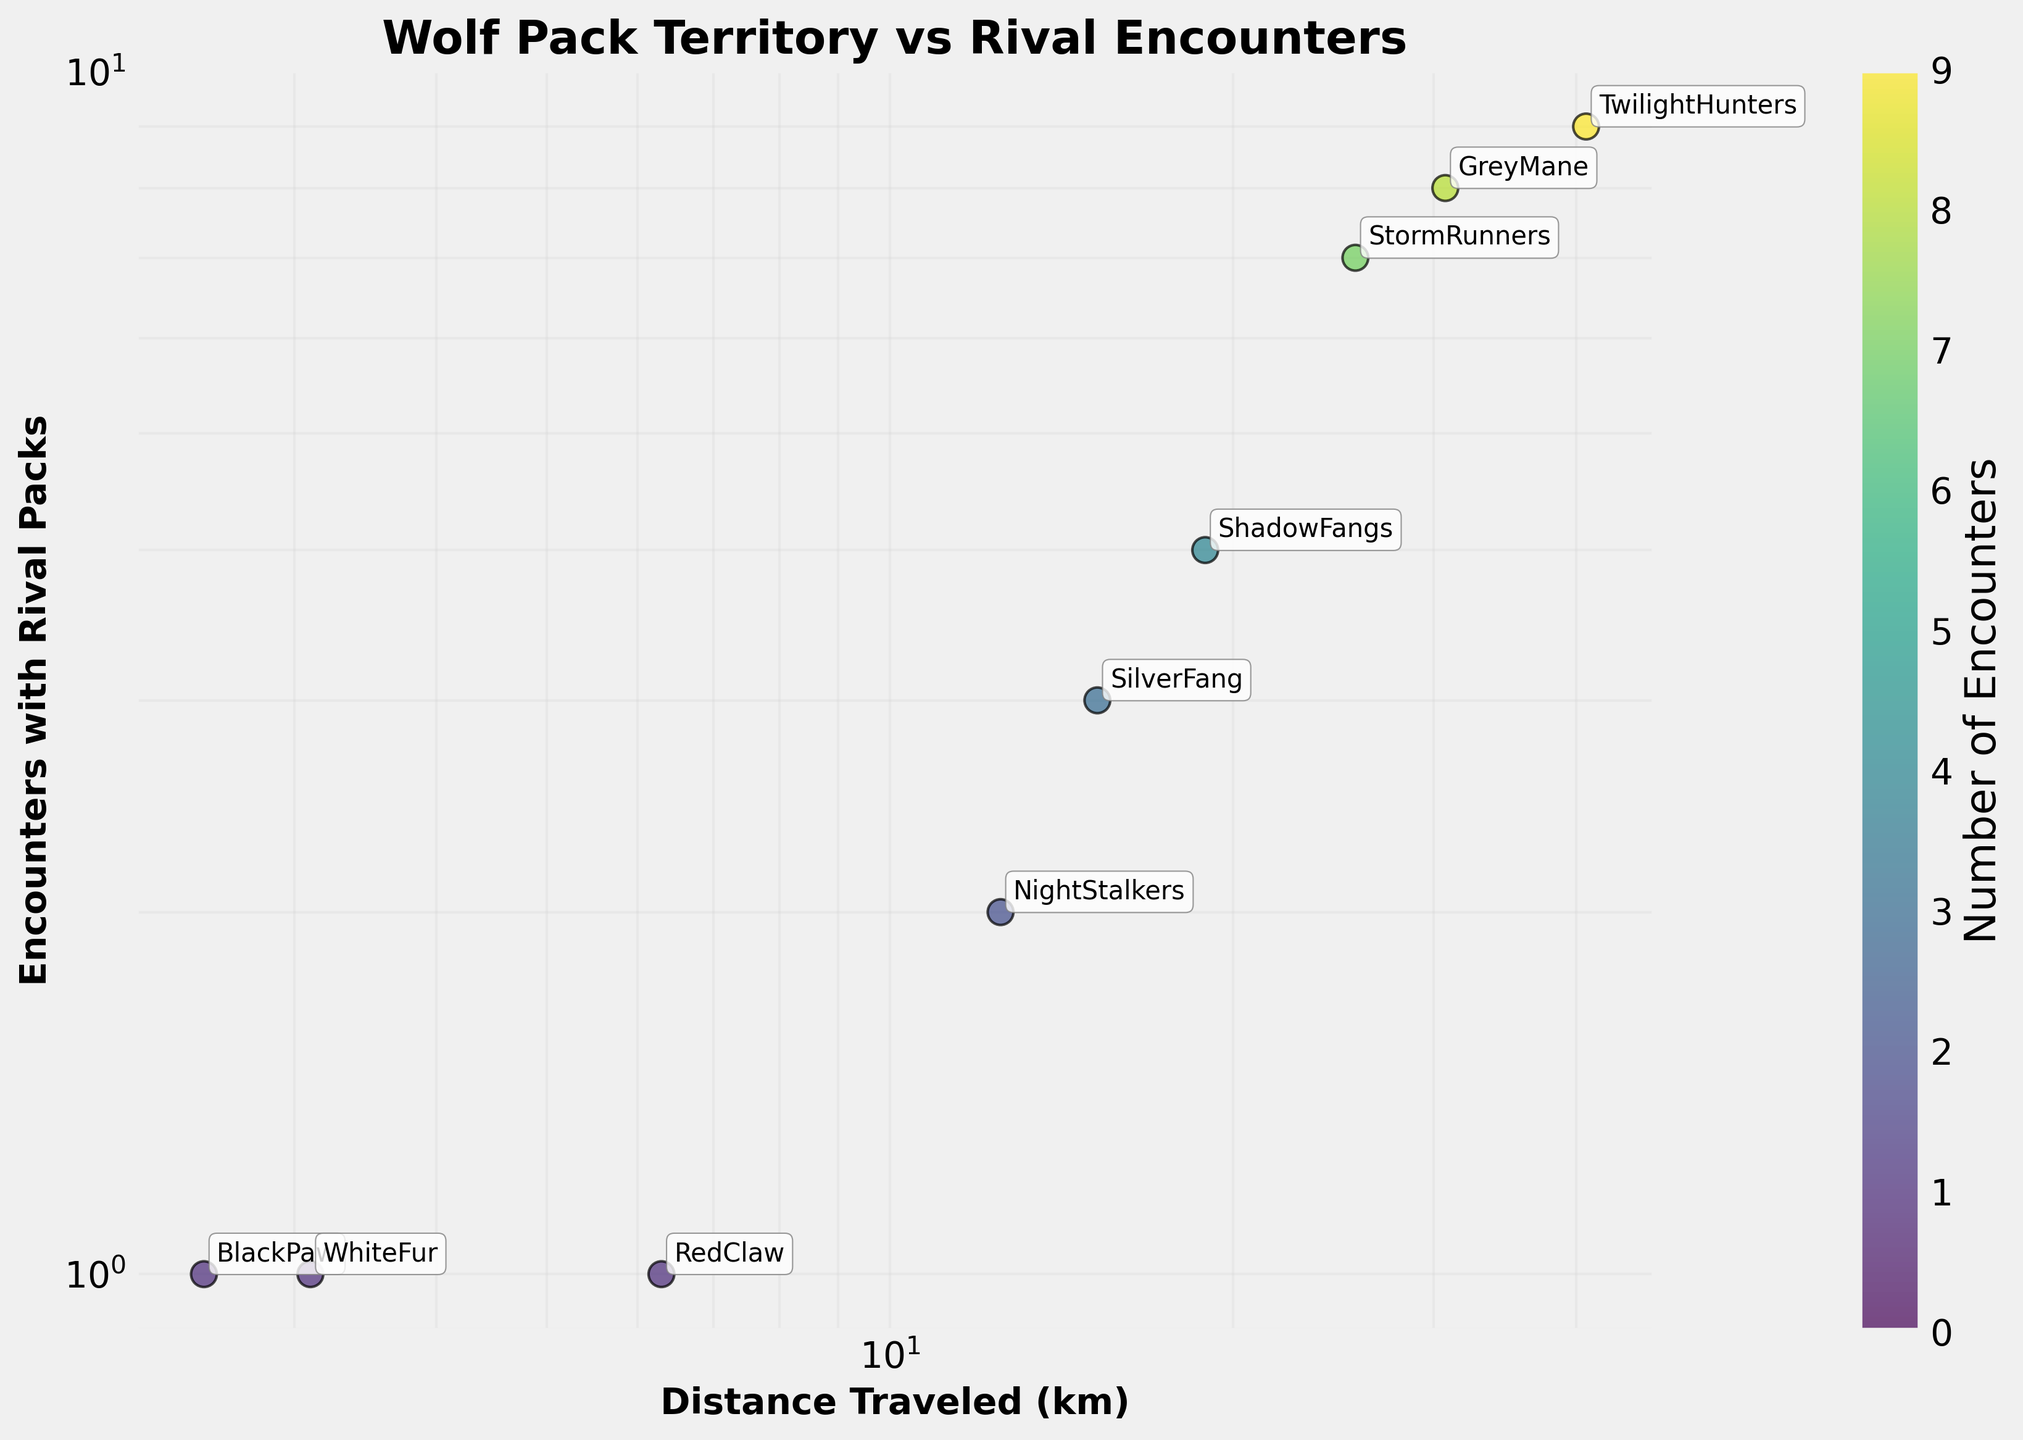How many packs are represented in the figure? To determine the number of packs, count the individual data points or labels corresponding to each pack. The figure shows 10 distinct pack names (BlackPaw, SilverFang, MoonHowler, StormRunners, WhiteFur, NightStalkers, TwilightHunters, ShadowFangs, RedClaw, GreyMane).
Answer: 10 Which pack traveled the shortest distance? To find the pack with the shortest distance traveled, look for the data point positioned lowest on the x-axis, which is on a log scale. According to the data, BlackPaw traveled 2.5 km, which is the smallest distance.
Answer: BlackPaw How many encounters did the TwilightHunters have? To find the number of encounters for a specific pack, locate the data point for TwilightHunters and read the corresponding value on the y-axis, which is on a log scale. TwilightHunters had 9 encounters.
Answer: 9 Which pack encountered rivals the most often? Compare the y-axis values of all data points to find the maximum. The TwilightHunters encountered rivals the most often with 9 encounters.
Answer: TwilightHunters What is the relationship between distance traveled and encounters with rivals? Observe the general trend in the scatter plot. As the distance traveled increases, the frequency of encounters with rival packs also tends to increase, suggesting a positive correlation between the two variables.
Answer: Positive correlation Which packs traveled more than 20 km? Identify data points on the x-axis with values greater than 20 km and check their corresponding pack names. The packs are StormRunners (25.6 km), TwilightHunters (40.8 km), and GreyMane (30.7 km).
Answer: StormRunners, TwilightHunters, GreyMane Are there any packs that traveled more than 10 km but had fewer than 3 encounters? Identify data points where the x-axis value is greater than 10 km and the y-axis value is less than 3. The pack NightStalkers fits this criteria, having traveled 12.5 km and had 2 encounters.
Answer: NightStalkers What is the median number of encounters among all packs? List all the number of encounters (1, 3, 0, 7, 1, 2, 9, 4, 1, 8) and find the middle value. First, sort the values: (0, 1, 1, 1, 2, 3, 4, 7, 8, 9). Counting 10 values, the median is the average of the 5th and 6th values, which are 2 and 3. The median is (2+3)/2 = 2.5.
Answer: 2.5 Which pack had the same number of encounters as WhiteFur? Identify the number of encounters for WhiteFur, which is 1, and find any other pack(s) with the same value. Both BlackPaw and RedClaw also had 1 encounter.
Answer: BlackPaw, RedClaw 